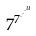<formula> <loc_0><loc_0><loc_500><loc_500>7 ^ { 7 ^ { \cdot ^ { \cdot ^ { \cdot ^ { u } } } } }</formula> 